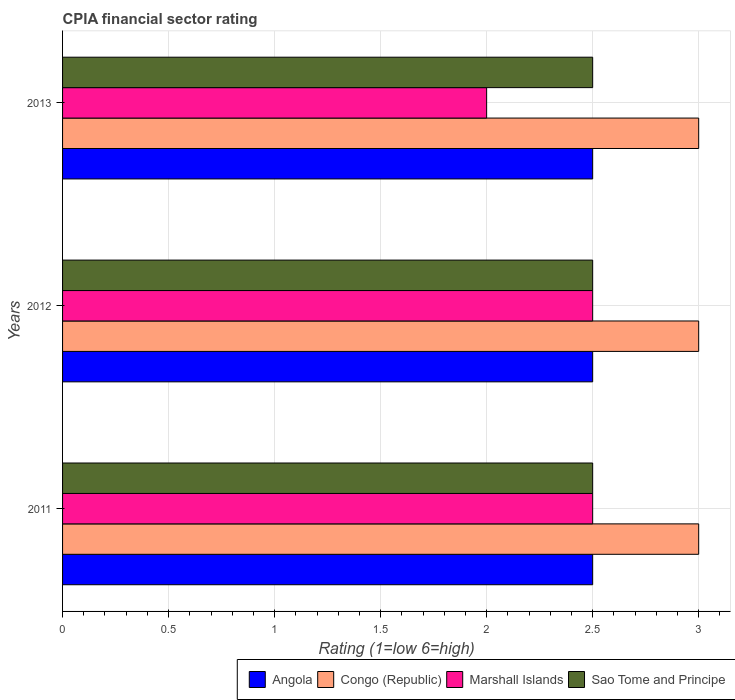How many different coloured bars are there?
Your answer should be very brief. 4. Are the number of bars per tick equal to the number of legend labels?
Provide a succinct answer. Yes. Are the number of bars on each tick of the Y-axis equal?
Your response must be concise. Yes. In how many cases, is the number of bars for a given year not equal to the number of legend labels?
Ensure brevity in your answer.  0. What is the CPIA rating in Angola in 2013?
Your answer should be very brief. 2.5. Across all years, what is the maximum CPIA rating in Marshall Islands?
Provide a short and direct response. 2.5. Across all years, what is the minimum CPIA rating in Angola?
Your response must be concise. 2.5. In which year was the CPIA rating in Angola maximum?
Provide a short and direct response. 2011. In which year was the CPIA rating in Marshall Islands minimum?
Keep it short and to the point. 2013. What is the total CPIA rating in Marshall Islands in the graph?
Your answer should be very brief. 7. What is the difference between the CPIA rating in Angola in 2013 and the CPIA rating in Sao Tome and Principe in 2012?
Keep it short and to the point. 0. What is the average CPIA rating in Marshall Islands per year?
Make the answer very short. 2.33. Is the CPIA rating in Marshall Islands in 2011 less than that in 2013?
Offer a very short reply. No. What is the difference between the highest and the second highest CPIA rating in Congo (Republic)?
Provide a succinct answer. 0. What does the 3rd bar from the top in 2012 represents?
Make the answer very short. Congo (Republic). What does the 2nd bar from the bottom in 2013 represents?
Offer a very short reply. Congo (Republic). Is it the case that in every year, the sum of the CPIA rating in Marshall Islands and CPIA rating in Congo (Republic) is greater than the CPIA rating in Angola?
Give a very brief answer. Yes. How many bars are there?
Your answer should be compact. 12. Are all the bars in the graph horizontal?
Provide a short and direct response. Yes. How many years are there in the graph?
Your answer should be very brief. 3. What is the difference between two consecutive major ticks on the X-axis?
Your answer should be very brief. 0.5. Does the graph contain any zero values?
Ensure brevity in your answer.  No. Does the graph contain grids?
Provide a short and direct response. Yes. Where does the legend appear in the graph?
Offer a terse response. Bottom right. How many legend labels are there?
Make the answer very short. 4. How are the legend labels stacked?
Offer a very short reply. Horizontal. What is the title of the graph?
Provide a succinct answer. CPIA financial sector rating. Does "Armenia" appear as one of the legend labels in the graph?
Ensure brevity in your answer.  No. What is the label or title of the X-axis?
Your answer should be compact. Rating (1=low 6=high). What is the Rating (1=low 6=high) of Angola in 2011?
Provide a succinct answer. 2.5. What is the Rating (1=low 6=high) of Congo (Republic) in 2011?
Give a very brief answer. 3. What is the Rating (1=low 6=high) in Sao Tome and Principe in 2011?
Give a very brief answer. 2.5. What is the Rating (1=low 6=high) in Angola in 2012?
Your response must be concise. 2.5. What is the Rating (1=low 6=high) in Congo (Republic) in 2012?
Offer a terse response. 3. What is the Rating (1=low 6=high) in Sao Tome and Principe in 2012?
Offer a terse response. 2.5. What is the Rating (1=low 6=high) of Congo (Republic) in 2013?
Keep it short and to the point. 3. What is the Rating (1=low 6=high) in Marshall Islands in 2013?
Give a very brief answer. 2. Across all years, what is the maximum Rating (1=low 6=high) of Angola?
Keep it short and to the point. 2.5. Across all years, what is the maximum Rating (1=low 6=high) of Congo (Republic)?
Offer a terse response. 3. Across all years, what is the maximum Rating (1=low 6=high) in Sao Tome and Principe?
Ensure brevity in your answer.  2.5. Across all years, what is the minimum Rating (1=low 6=high) of Marshall Islands?
Provide a succinct answer. 2. What is the total Rating (1=low 6=high) of Angola in the graph?
Provide a short and direct response. 7.5. What is the total Rating (1=low 6=high) of Congo (Republic) in the graph?
Provide a succinct answer. 9. What is the total Rating (1=low 6=high) in Marshall Islands in the graph?
Give a very brief answer. 7. What is the total Rating (1=low 6=high) in Sao Tome and Principe in the graph?
Provide a short and direct response. 7.5. What is the difference between the Rating (1=low 6=high) in Marshall Islands in 2011 and that in 2012?
Make the answer very short. 0. What is the difference between the Rating (1=low 6=high) of Sao Tome and Principe in 2011 and that in 2012?
Provide a short and direct response. 0. What is the difference between the Rating (1=low 6=high) of Congo (Republic) in 2011 and that in 2013?
Provide a succinct answer. 0. What is the difference between the Rating (1=low 6=high) in Sao Tome and Principe in 2011 and that in 2013?
Your answer should be compact. 0. What is the difference between the Rating (1=low 6=high) of Angola in 2011 and the Rating (1=low 6=high) of Marshall Islands in 2012?
Make the answer very short. 0. What is the difference between the Rating (1=low 6=high) of Angola in 2011 and the Rating (1=low 6=high) of Sao Tome and Principe in 2012?
Offer a very short reply. 0. What is the difference between the Rating (1=low 6=high) of Congo (Republic) in 2011 and the Rating (1=low 6=high) of Marshall Islands in 2012?
Make the answer very short. 0.5. What is the difference between the Rating (1=low 6=high) of Congo (Republic) in 2011 and the Rating (1=low 6=high) of Sao Tome and Principe in 2012?
Ensure brevity in your answer.  0.5. What is the difference between the Rating (1=low 6=high) of Marshall Islands in 2011 and the Rating (1=low 6=high) of Sao Tome and Principe in 2012?
Keep it short and to the point. 0. What is the difference between the Rating (1=low 6=high) in Angola in 2011 and the Rating (1=low 6=high) in Congo (Republic) in 2013?
Offer a terse response. -0.5. What is the difference between the Rating (1=low 6=high) in Angola in 2011 and the Rating (1=low 6=high) in Sao Tome and Principe in 2013?
Offer a very short reply. 0. What is the difference between the Rating (1=low 6=high) of Congo (Republic) in 2011 and the Rating (1=low 6=high) of Marshall Islands in 2013?
Your answer should be compact. 1. What is the difference between the Rating (1=low 6=high) in Angola in 2012 and the Rating (1=low 6=high) in Sao Tome and Principe in 2013?
Offer a very short reply. 0. What is the difference between the Rating (1=low 6=high) of Congo (Republic) in 2012 and the Rating (1=low 6=high) of Marshall Islands in 2013?
Give a very brief answer. 1. What is the difference between the Rating (1=low 6=high) of Congo (Republic) in 2012 and the Rating (1=low 6=high) of Sao Tome and Principe in 2013?
Provide a short and direct response. 0.5. What is the average Rating (1=low 6=high) in Congo (Republic) per year?
Keep it short and to the point. 3. What is the average Rating (1=low 6=high) of Marshall Islands per year?
Make the answer very short. 2.33. In the year 2011, what is the difference between the Rating (1=low 6=high) of Angola and Rating (1=low 6=high) of Congo (Republic)?
Give a very brief answer. -0.5. In the year 2011, what is the difference between the Rating (1=low 6=high) of Congo (Republic) and Rating (1=low 6=high) of Marshall Islands?
Give a very brief answer. 0.5. In the year 2011, what is the difference between the Rating (1=low 6=high) in Congo (Republic) and Rating (1=low 6=high) in Sao Tome and Principe?
Your answer should be compact. 0.5. In the year 2011, what is the difference between the Rating (1=low 6=high) in Marshall Islands and Rating (1=low 6=high) in Sao Tome and Principe?
Keep it short and to the point. 0. In the year 2012, what is the difference between the Rating (1=low 6=high) of Marshall Islands and Rating (1=low 6=high) of Sao Tome and Principe?
Make the answer very short. 0. In the year 2013, what is the difference between the Rating (1=low 6=high) of Angola and Rating (1=low 6=high) of Congo (Republic)?
Ensure brevity in your answer.  -0.5. In the year 2013, what is the difference between the Rating (1=low 6=high) in Congo (Republic) and Rating (1=low 6=high) in Sao Tome and Principe?
Your response must be concise. 0.5. What is the ratio of the Rating (1=low 6=high) in Congo (Republic) in 2011 to that in 2012?
Give a very brief answer. 1. What is the ratio of the Rating (1=low 6=high) of Marshall Islands in 2011 to that in 2012?
Your answer should be compact. 1. What is the ratio of the Rating (1=low 6=high) in Sao Tome and Principe in 2011 to that in 2012?
Ensure brevity in your answer.  1. What is the ratio of the Rating (1=low 6=high) of Congo (Republic) in 2011 to that in 2013?
Give a very brief answer. 1. What is the ratio of the Rating (1=low 6=high) in Marshall Islands in 2011 to that in 2013?
Make the answer very short. 1.25. What is the ratio of the Rating (1=low 6=high) of Sao Tome and Principe in 2011 to that in 2013?
Give a very brief answer. 1. What is the ratio of the Rating (1=low 6=high) of Marshall Islands in 2012 to that in 2013?
Provide a short and direct response. 1.25. What is the difference between the highest and the lowest Rating (1=low 6=high) in Angola?
Keep it short and to the point. 0. What is the difference between the highest and the lowest Rating (1=low 6=high) in Congo (Republic)?
Keep it short and to the point. 0. What is the difference between the highest and the lowest Rating (1=low 6=high) in Marshall Islands?
Make the answer very short. 0.5. 